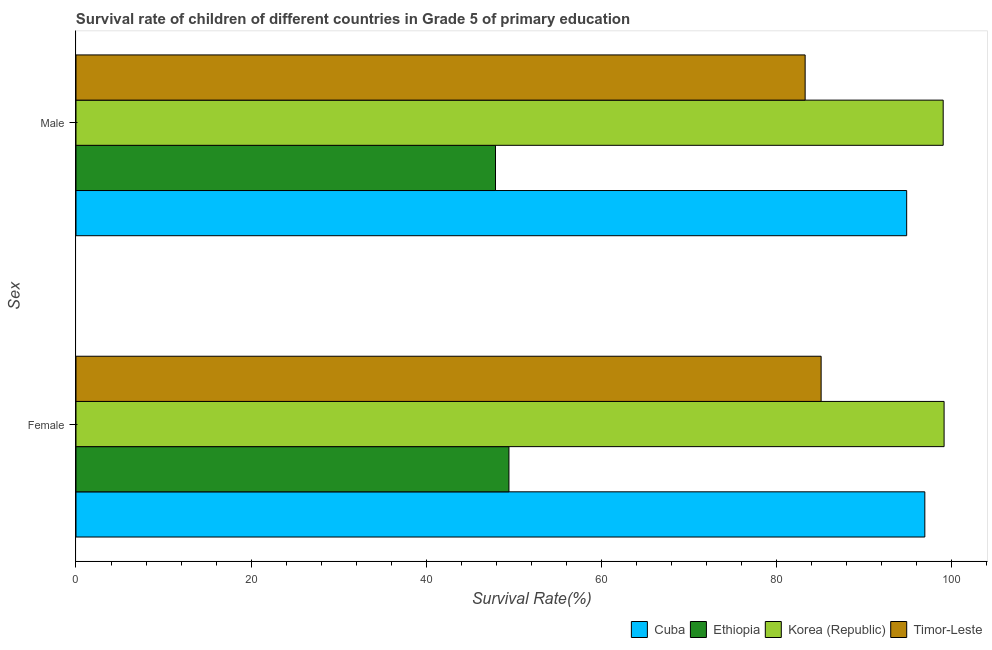Are the number of bars per tick equal to the number of legend labels?
Ensure brevity in your answer.  Yes. What is the survival rate of female students in primary education in Ethiopia?
Ensure brevity in your answer.  49.47. Across all countries, what is the maximum survival rate of female students in primary education?
Keep it short and to the point. 99.18. Across all countries, what is the minimum survival rate of female students in primary education?
Ensure brevity in your answer.  49.47. In which country was the survival rate of male students in primary education maximum?
Your response must be concise. Korea (Republic). In which country was the survival rate of male students in primary education minimum?
Provide a short and direct response. Ethiopia. What is the total survival rate of male students in primary education in the graph?
Your answer should be very brief. 325.23. What is the difference between the survival rate of female students in primary education in Cuba and that in Timor-Leste?
Your answer should be very brief. 11.85. What is the difference between the survival rate of female students in primary education in Korea (Republic) and the survival rate of male students in primary education in Cuba?
Provide a succinct answer. 4.28. What is the average survival rate of male students in primary education per country?
Keep it short and to the point. 81.31. What is the difference between the survival rate of female students in primary education and survival rate of male students in primary education in Cuba?
Offer a terse response. 2.08. In how many countries, is the survival rate of female students in primary education greater than 20 %?
Provide a succinct answer. 4. What is the ratio of the survival rate of female students in primary education in Cuba to that in Korea (Republic)?
Ensure brevity in your answer.  0.98. Is the survival rate of female students in primary education in Korea (Republic) less than that in Timor-Leste?
Give a very brief answer. No. In how many countries, is the survival rate of male students in primary education greater than the average survival rate of male students in primary education taken over all countries?
Offer a very short reply. 3. What does the 2nd bar from the top in Female represents?
Provide a succinct answer. Korea (Republic). What does the 3rd bar from the bottom in Female represents?
Provide a short and direct response. Korea (Republic). How many bars are there?
Ensure brevity in your answer.  8. Are all the bars in the graph horizontal?
Keep it short and to the point. Yes. What is the difference between two consecutive major ticks on the X-axis?
Make the answer very short. 20. Does the graph contain any zero values?
Your response must be concise. No. Where does the legend appear in the graph?
Keep it short and to the point. Bottom right. How many legend labels are there?
Your answer should be very brief. 4. How are the legend labels stacked?
Offer a terse response. Horizontal. What is the title of the graph?
Provide a short and direct response. Survival rate of children of different countries in Grade 5 of primary education. What is the label or title of the X-axis?
Your answer should be very brief. Survival Rate(%). What is the label or title of the Y-axis?
Your response must be concise. Sex. What is the Survival Rate(%) in Cuba in Female?
Provide a succinct answer. 96.98. What is the Survival Rate(%) of Ethiopia in Female?
Ensure brevity in your answer.  49.47. What is the Survival Rate(%) in Korea (Republic) in Female?
Provide a succinct answer. 99.18. What is the Survival Rate(%) of Timor-Leste in Female?
Offer a terse response. 85.14. What is the Survival Rate(%) of Cuba in Male?
Keep it short and to the point. 94.91. What is the Survival Rate(%) in Ethiopia in Male?
Give a very brief answer. 47.93. What is the Survival Rate(%) in Korea (Republic) in Male?
Give a very brief answer. 99.08. What is the Survival Rate(%) of Timor-Leste in Male?
Your answer should be compact. 83.31. Across all Sex, what is the maximum Survival Rate(%) in Cuba?
Offer a terse response. 96.98. Across all Sex, what is the maximum Survival Rate(%) in Ethiopia?
Your answer should be very brief. 49.47. Across all Sex, what is the maximum Survival Rate(%) of Korea (Republic)?
Offer a terse response. 99.18. Across all Sex, what is the maximum Survival Rate(%) of Timor-Leste?
Offer a terse response. 85.14. Across all Sex, what is the minimum Survival Rate(%) in Cuba?
Offer a very short reply. 94.91. Across all Sex, what is the minimum Survival Rate(%) of Ethiopia?
Your answer should be very brief. 47.93. Across all Sex, what is the minimum Survival Rate(%) of Korea (Republic)?
Your answer should be compact. 99.08. Across all Sex, what is the minimum Survival Rate(%) in Timor-Leste?
Provide a succinct answer. 83.31. What is the total Survival Rate(%) of Cuba in the graph?
Keep it short and to the point. 191.89. What is the total Survival Rate(%) of Ethiopia in the graph?
Your answer should be very brief. 97.4. What is the total Survival Rate(%) in Korea (Republic) in the graph?
Offer a very short reply. 198.27. What is the total Survival Rate(%) in Timor-Leste in the graph?
Give a very brief answer. 168.44. What is the difference between the Survival Rate(%) of Cuba in Female and that in Male?
Offer a terse response. 2.08. What is the difference between the Survival Rate(%) in Ethiopia in Female and that in Male?
Your response must be concise. 1.54. What is the difference between the Survival Rate(%) in Korea (Republic) in Female and that in Male?
Ensure brevity in your answer.  0.1. What is the difference between the Survival Rate(%) of Timor-Leste in Female and that in Male?
Make the answer very short. 1.83. What is the difference between the Survival Rate(%) of Cuba in Female and the Survival Rate(%) of Ethiopia in Male?
Your response must be concise. 49.05. What is the difference between the Survival Rate(%) of Cuba in Female and the Survival Rate(%) of Korea (Republic) in Male?
Your response must be concise. -2.1. What is the difference between the Survival Rate(%) in Cuba in Female and the Survival Rate(%) in Timor-Leste in Male?
Your answer should be compact. 13.67. What is the difference between the Survival Rate(%) in Ethiopia in Female and the Survival Rate(%) in Korea (Republic) in Male?
Give a very brief answer. -49.61. What is the difference between the Survival Rate(%) of Ethiopia in Female and the Survival Rate(%) of Timor-Leste in Male?
Make the answer very short. -33.84. What is the difference between the Survival Rate(%) of Korea (Republic) in Female and the Survival Rate(%) of Timor-Leste in Male?
Ensure brevity in your answer.  15.87. What is the average Survival Rate(%) in Cuba per Sex?
Make the answer very short. 95.95. What is the average Survival Rate(%) of Ethiopia per Sex?
Give a very brief answer. 48.7. What is the average Survival Rate(%) in Korea (Republic) per Sex?
Offer a very short reply. 99.13. What is the average Survival Rate(%) of Timor-Leste per Sex?
Your response must be concise. 84.22. What is the difference between the Survival Rate(%) of Cuba and Survival Rate(%) of Ethiopia in Female?
Provide a short and direct response. 47.52. What is the difference between the Survival Rate(%) in Cuba and Survival Rate(%) in Korea (Republic) in Female?
Provide a succinct answer. -2.2. What is the difference between the Survival Rate(%) of Cuba and Survival Rate(%) of Timor-Leste in Female?
Make the answer very short. 11.85. What is the difference between the Survival Rate(%) of Ethiopia and Survival Rate(%) of Korea (Republic) in Female?
Provide a short and direct response. -49.72. What is the difference between the Survival Rate(%) of Ethiopia and Survival Rate(%) of Timor-Leste in Female?
Make the answer very short. -35.67. What is the difference between the Survival Rate(%) of Korea (Republic) and Survival Rate(%) of Timor-Leste in Female?
Your answer should be very brief. 14.05. What is the difference between the Survival Rate(%) of Cuba and Survival Rate(%) of Ethiopia in Male?
Provide a succinct answer. 46.98. What is the difference between the Survival Rate(%) of Cuba and Survival Rate(%) of Korea (Republic) in Male?
Make the answer very short. -4.17. What is the difference between the Survival Rate(%) in Cuba and Survival Rate(%) in Timor-Leste in Male?
Provide a succinct answer. 11.6. What is the difference between the Survival Rate(%) in Ethiopia and Survival Rate(%) in Korea (Republic) in Male?
Make the answer very short. -51.15. What is the difference between the Survival Rate(%) of Ethiopia and Survival Rate(%) of Timor-Leste in Male?
Offer a very short reply. -35.38. What is the difference between the Survival Rate(%) in Korea (Republic) and Survival Rate(%) in Timor-Leste in Male?
Your answer should be very brief. 15.77. What is the ratio of the Survival Rate(%) of Cuba in Female to that in Male?
Make the answer very short. 1.02. What is the ratio of the Survival Rate(%) in Ethiopia in Female to that in Male?
Your response must be concise. 1.03. What is the ratio of the Survival Rate(%) of Timor-Leste in Female to that in Male?
Your answer should be very brief. 1.02. What is the difference between the highest and the second highest Survival Rate(%) of Cuba?
Provide a short and direct response. 2.08. What is the difference between the highest and the second highest Survival Rate(%) in Ethiopia?
Make the answer very short. 1.54. What is the difference between the highest and the second highest Survival Rate(%) of Korea (Republic)?
Make the answer very short. 0.1. What is the difference between the highest and the second highest Survival Rate(%) of Timor-Leste?
Keep it short and to the point. 1.83. What is the difference between the highest and the lowest Survival Rate(%) in Cuba?
Keep it short and to the point. 2.08. What is the difference between the highest and the lowest Survival Rate(%) of Ethiopia?
Your response must be concise. 1.54. What is the difference between the highest and the lowest Survival Rate(%) in Korea (Republic)?
Keep it short and to the point. 0.1. What is the difference between the highest and the lowest Survival Rate(%) in Timor-Leste?
Provide a succinct answer. 1.83. 